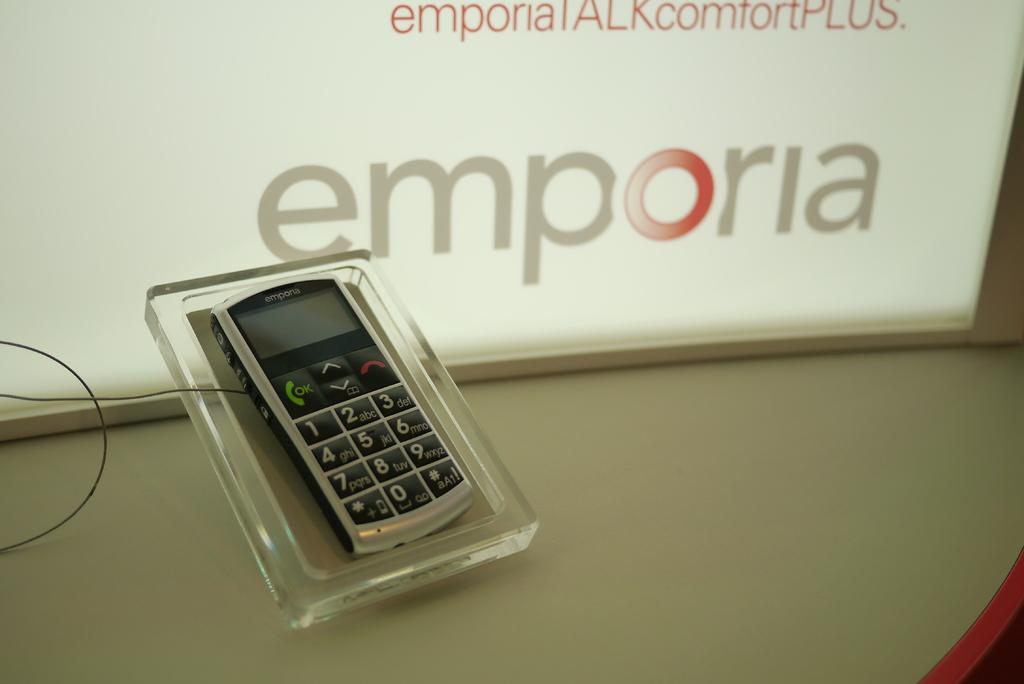<image>
Give a short and clear explanation of the subsequent image. the word emporia that is on a phone 